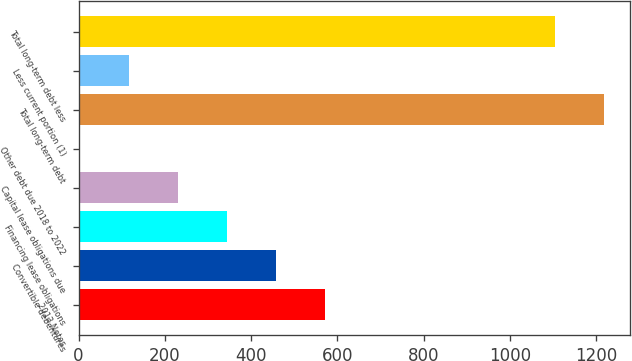Convert chart to OTSL. <chart><loc_0><loc_0><loc_500><loc_500><bar_chart><fcel>2013 Notes<fcel>Convertible debentures<fcel>Financing lease obligations<fcel>Capital lease obligations due<fcel>Other debt due 2018 to 2022<fcel>Total long-term debt<fcel>Less current portion (1)<fcel>Total long-term debt less<nl><fcel>570.5<fcel>456.8<fcel>343.1<fcel>229.4<fcel>2<fcel>1217.7<fcel>115.7<fcel>1104<nl></chart> 